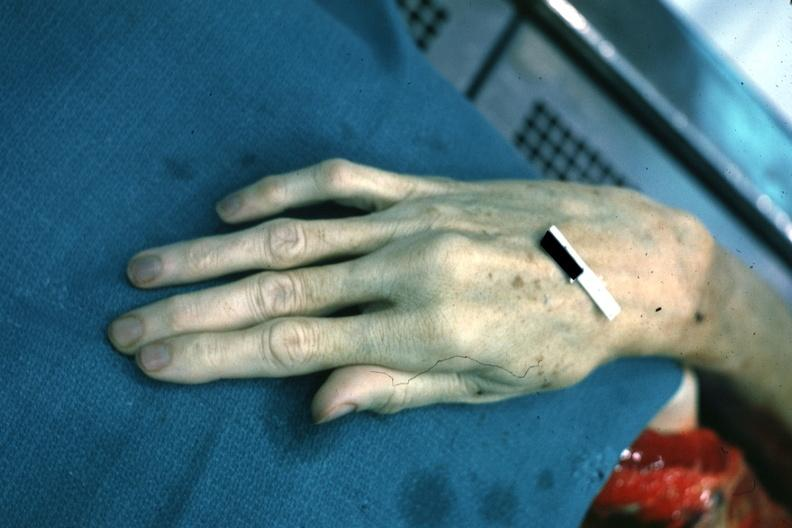does immunostain for growth hormone show dead typical very long fingers?
Answer the question using a single word or phrase. No 